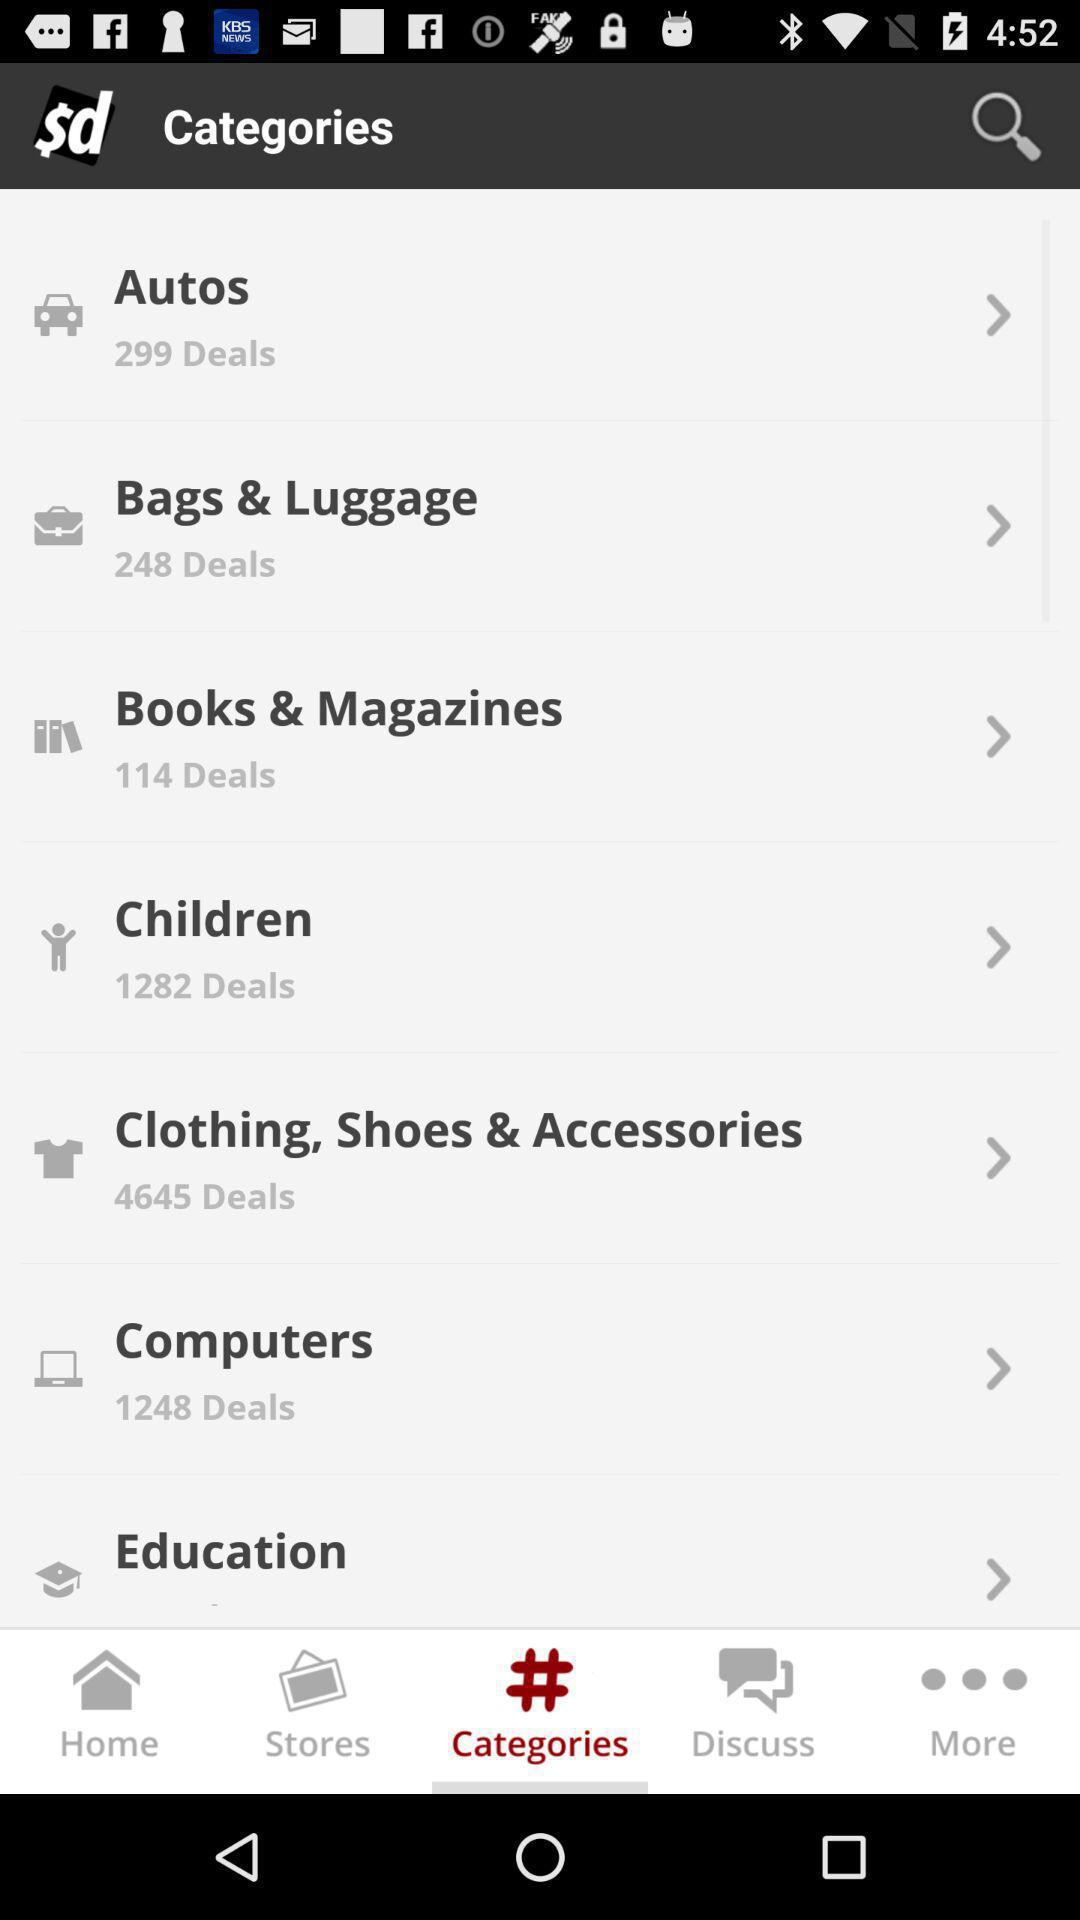Which tab is selected? The selected tab is "Categories". 